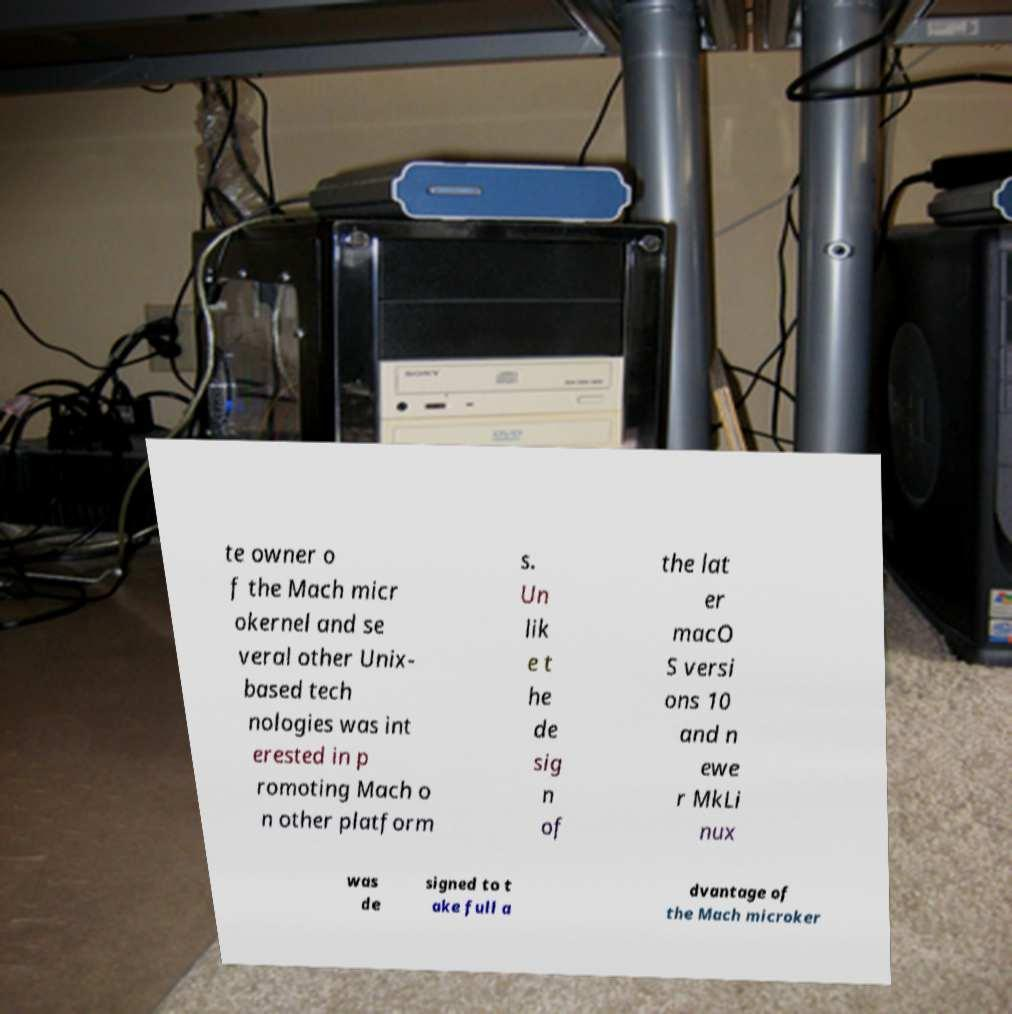Could you assist in decoding the text presented in this image and type it out clearly? te owner o f the Mach micr okernel and se veral other Unix- based tech nologies was int erested in p romoting Mach o n other platform s. Un lik e t he de sig n of the lat er macO S versi ons 10 and n ewe r MkLi nux was de signed to t ake full a dvantage of the Mach microker 